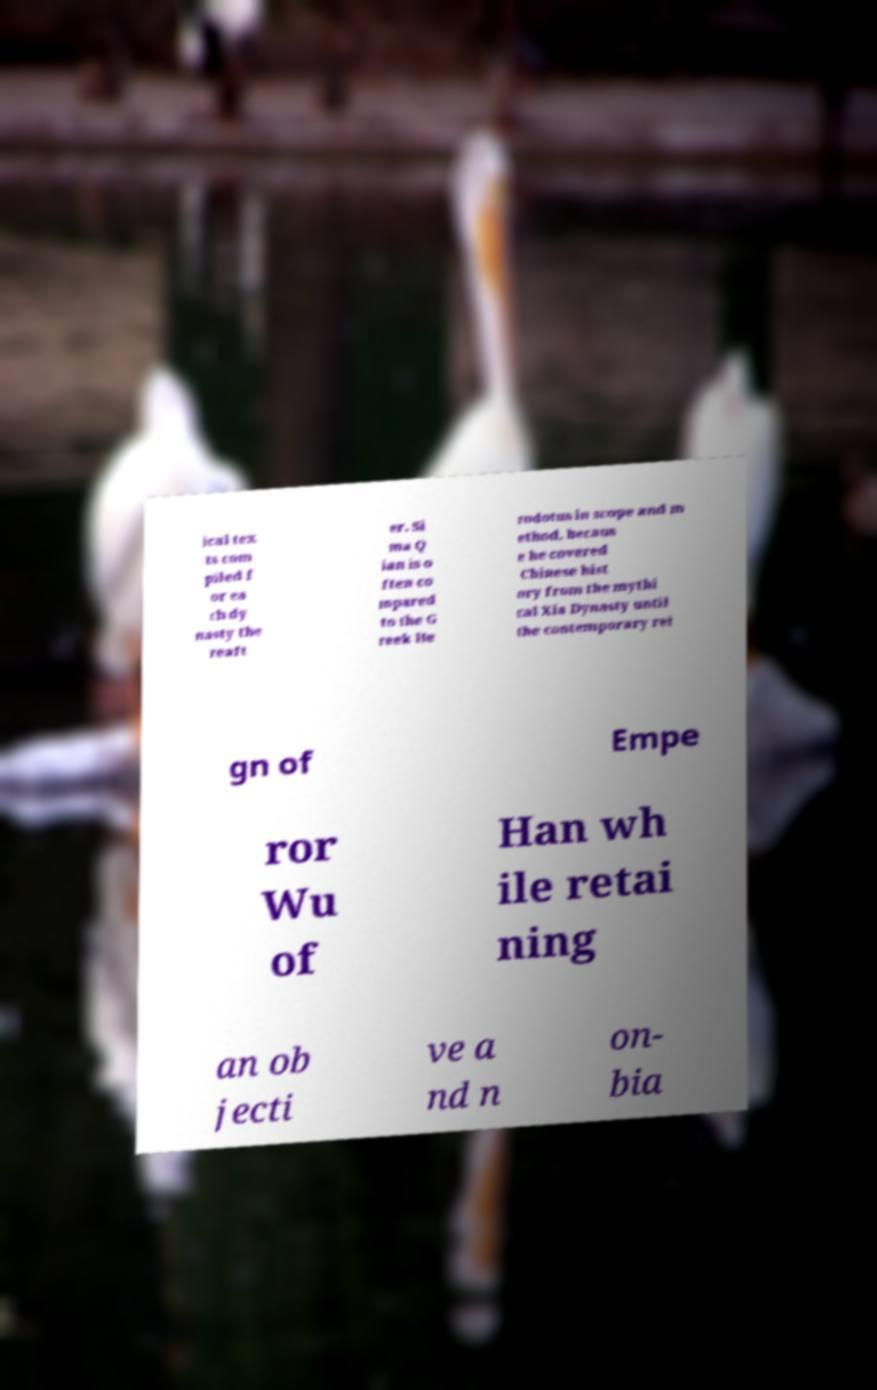There's text embedded in this image that I need extracted. Can you transcribe it verbatim? ical tex ts com piled f or ea ch dy nasty the reaft er. Si ma Q ian is o ften co mpared to the G reek He rodotus in scope and m ethod, becaus e he covered Chinese hist ory from the mythi cal Xia Dynasty until the contemporary rei gn of Empe ror Wu of Han wh ile retai ning an ob jecti ve a nd n on- bia 